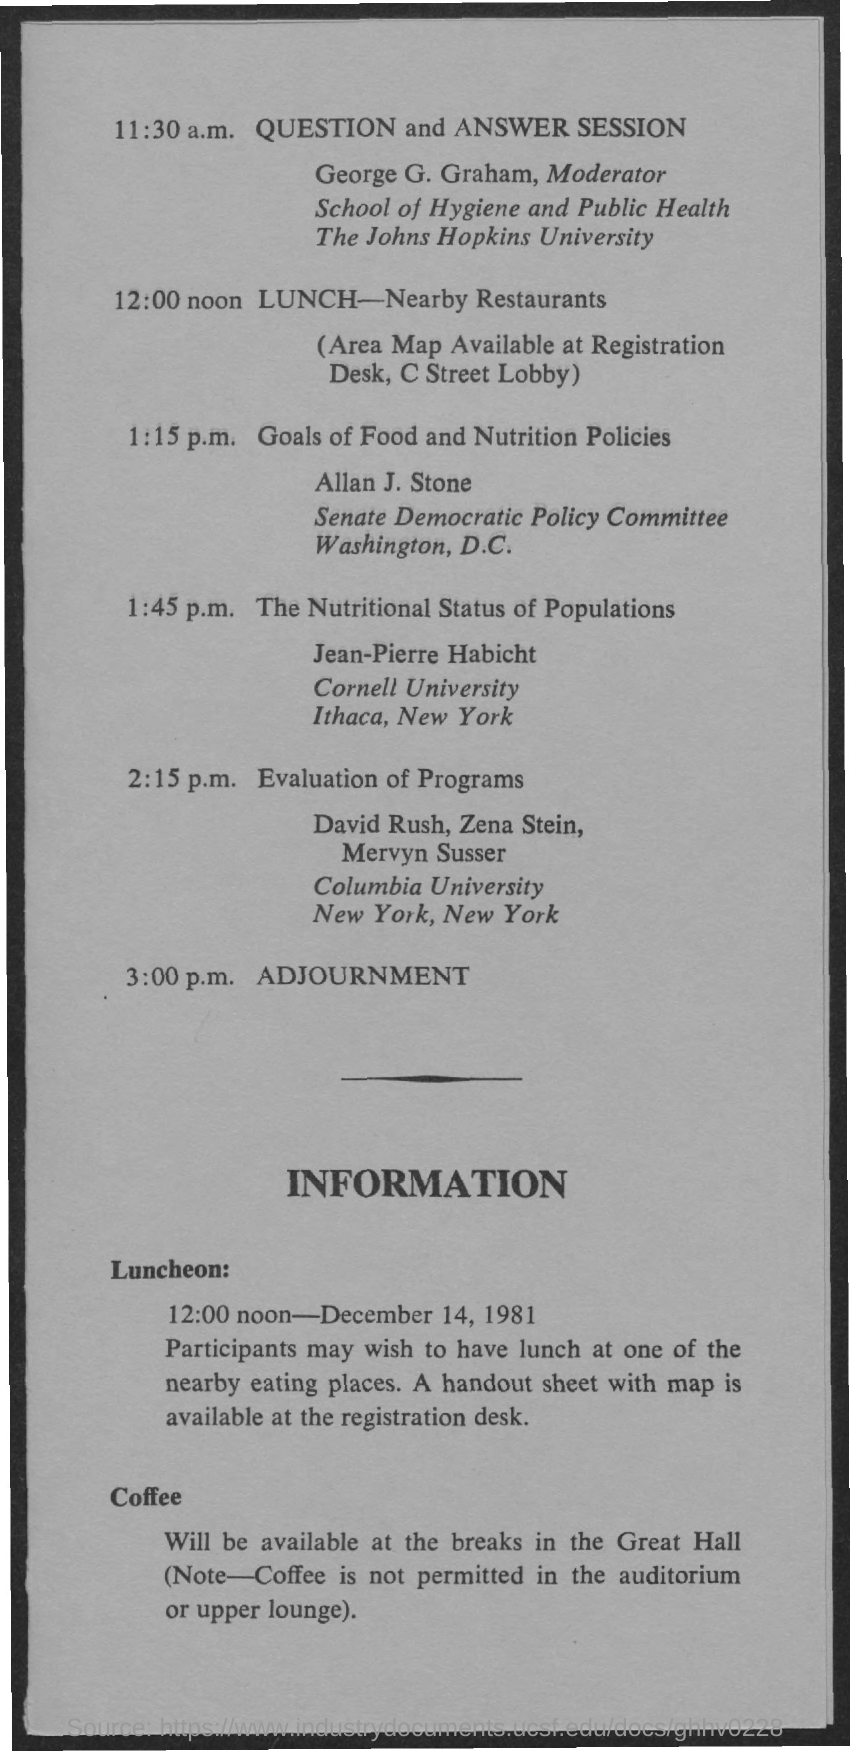List a handful of essential elements in this visual. The session on "Goals of Food and Nutrition Policies" is being presented by Allan J. Stone. The question and answer session is scheduled for 11:30 a.m. The sessions are adjourned at 3:00 p.m. The lunch will be organized at 12:00 noon. Jean-Pierre Habicht conducted the session titled "The Nutritional Status of Populations. 